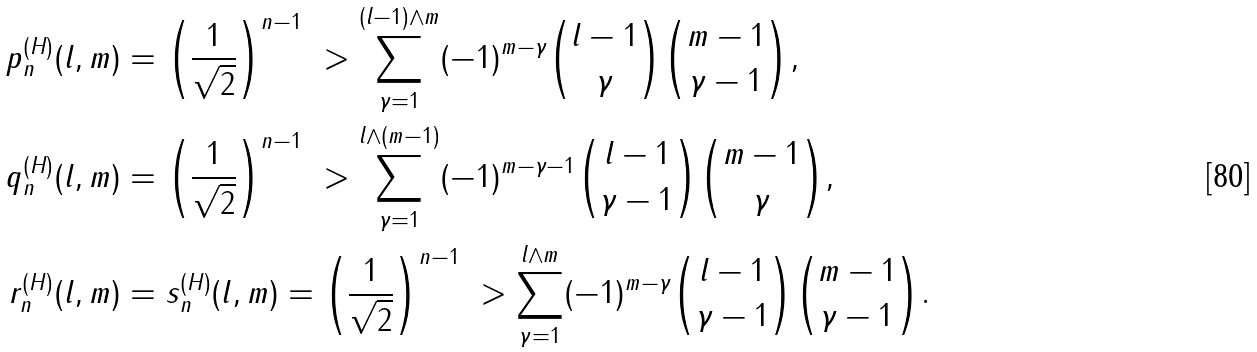<formula> <loc_0><loc_0><loc_500><loc_500>p ^ { ( H ) } _ { n } ( l , m ) & = \left ( \frac { 1 } { \sqrt { 2 } } \right ) ^ { n - 1 } \ > \sum _ { \gamma = 1 } ^ { ( l - 1 ) \wedge m } ( - 1 ) ^ { m - \gamma } { l - 1 \choose \gamma } { m - 1 \choose \gamma - 1 } , \\ q ^ { ( H ) } _ { n } ( l , m ) & = \left ( \frac { 1 } { \sqrt { 2 } } \right ) ^ { n - 1 } \ > \sum _ { \gamma = 1 } ^ { l \wedge ( m - 1 ) } ( - 1 ) ^ { m - \gamma - 1 } { l - 1 \choose \gamma - 1 } { m - 1 \choose \gamma } , \\ r ^ { ( H ) } _ { n } ( l , m ) & = s ^ { ( H ) } _ { n } ( l , m ) = \left ( \frac { 1 } { \sqrt { 2 } } \right ) ^ { n - 1 } \ > \sum _ { \gamma = 1 } ^ { l \wedge m } ( - 1 ) ^ { m - \gamma } { l - 1 \choose \gamma - 1 } { m - 1 \choose \gamma - 1 } .</formula> 